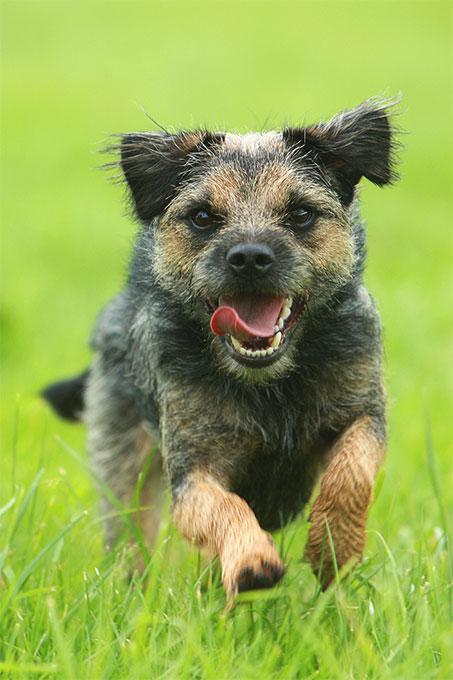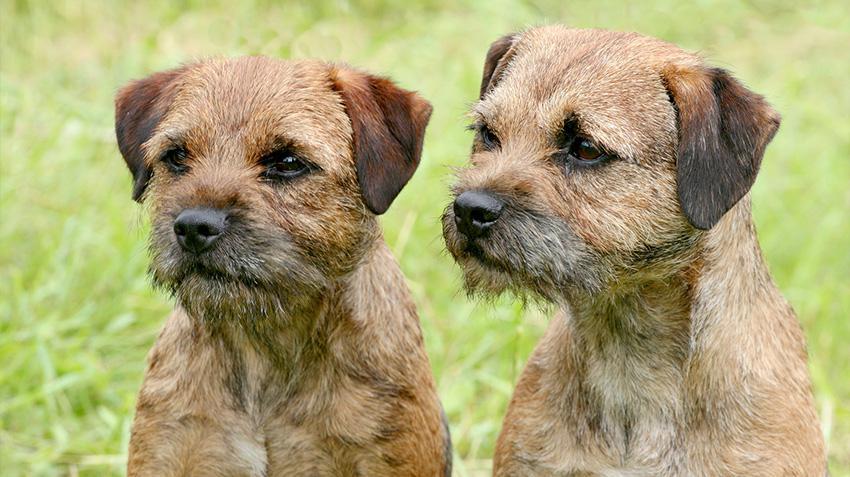The first image is the image on the left, the second image is the image on the right. Examine the images to the left and right. Is the description "An image shows two dogs together outdoors, and at least one dog is standing with its front paws balanced on something for support." accurate? Answer yes or no. No. The first image is the image on the left, the second image is the image on the right. Analyze the images presented: Is the assertion "The dog in the image on the left is running through the grass." valid? Answer yes or no. Yes. 